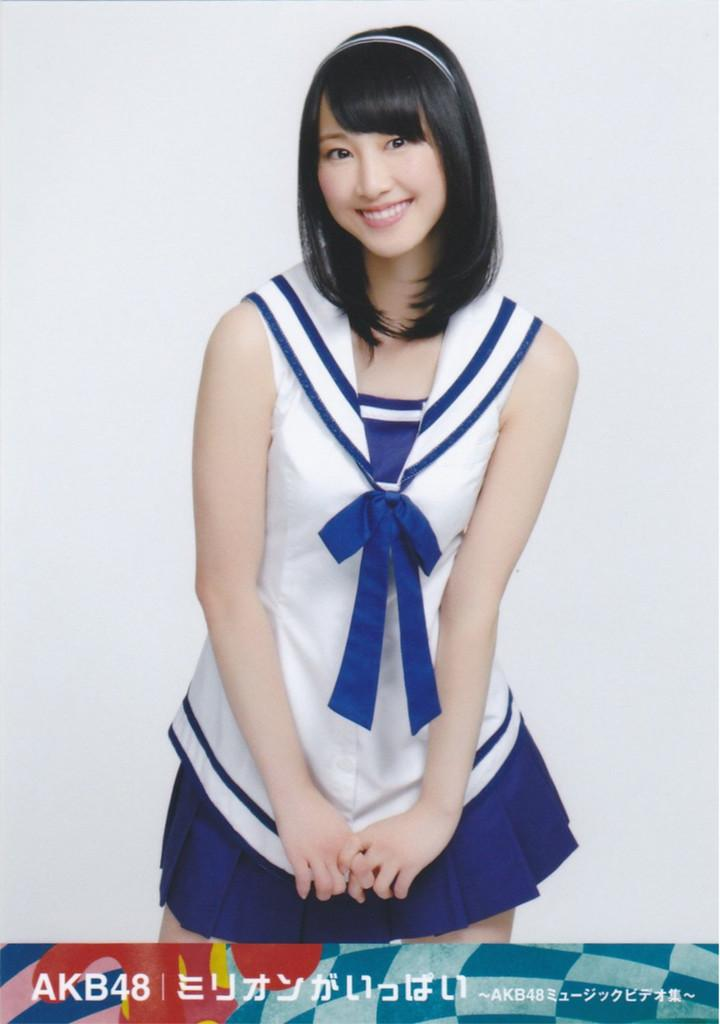<image>
Write a terse but informative summary of the picture. An asian woman in a blue and white costume with AKB48 at the bottom of the picture. 